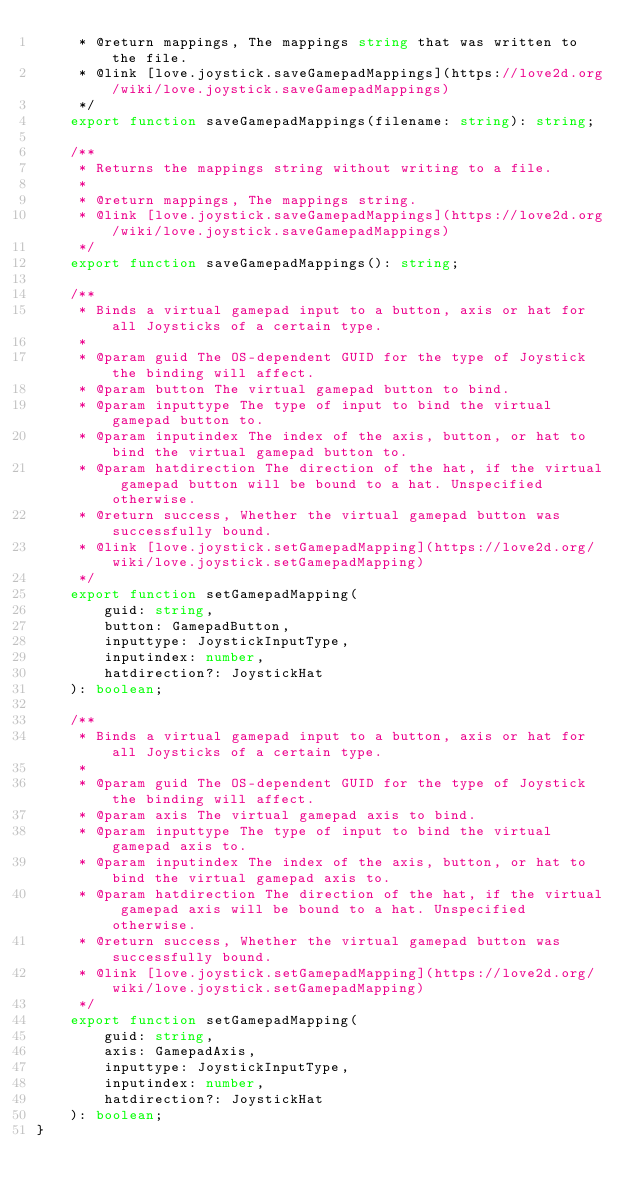<code> <loc_0><loc_0><loc_500><loc_500><_TypeScript_>     * @return mappings, The mappings string that was written to the file.
     * @link [love.joystick.saveGamepadMappings](https://love2d.org/wiki/love.joystick.saveGamepadMappings)
     */
    export function saveGamepadMappings(filename: string): string;

    /**
     * Returns the mappings string without writing to a file.
     *
     * @return mappings, The mappings string.
     * @link [love.joystick.saveGamepadMappings](https://love2d.org/wiki/love.joystick.saveGamepadMappings)
     */
    export function saveGamepadMappings(): string;

    /**
     * Binds a virtual gamepad input to a button, axis or hat for all Joysticks of a certain type.
     *
     * @param guid The OS-dependent GUID for the type of Joystick the binding will affect.
     * @param button The virtual gamepad button to bind.
     * @param inputtype The type of input to bind the virtual gamepad button to.
     * @param inputindex The index of the axis, button, or hat to bind the virtual gamepad button to.
     * @param hatdirection The direction of the hat, if the virtual gamepad button will be bound to a hat. Unspecified otherwise.
     * @return success, Whether the virtual gamepad button was successfully bound.
     * @link [love.joystick.setGamepadMapping](https://love2d.org/wiki/love.joystick.setGamepadMapping)
     */
    export function setGamepadMapping(
        guid: string,
        button: GamepadButton,
        inputtype: JoystickInputType,
        inputindex: number,
        hatdirection?: JoystickHat
    ): boolean;

    /**
     * Binds a virtual gamepad input to a button, axis or hat for all Joysticks of a certain type.
     *
     * @param guid The OS-dependent GUID for the type of Joystick the binding will affect.
     * @param axis The virtual gamepad axis to bind.
     * @param inputtype The type of input to bind the virtual gamepad axis to.
     * @param inputindex The index of the axis, button, or hat to bind the virtual gamepad axis to.
     * @param hatdirection The direction of the hat, if the virtual gamepad axis will be bound to a hat. Unspecified otherwise.
     * @return success, Whether the virtual gamepad button was successfully bound.
     * @link [love.joystick.setGamepadMapping](https://love2d.org/wiki/love.joystick.setGamepadMapping)
     */
    export function setGamepadMapping(
        guid: string,
        axis: GamepadAxis,
        inputtype: JoystickInputType,
        inputindex: number,
        hatdirection?: JoystickHat
    ): boolean;
}
</code> 